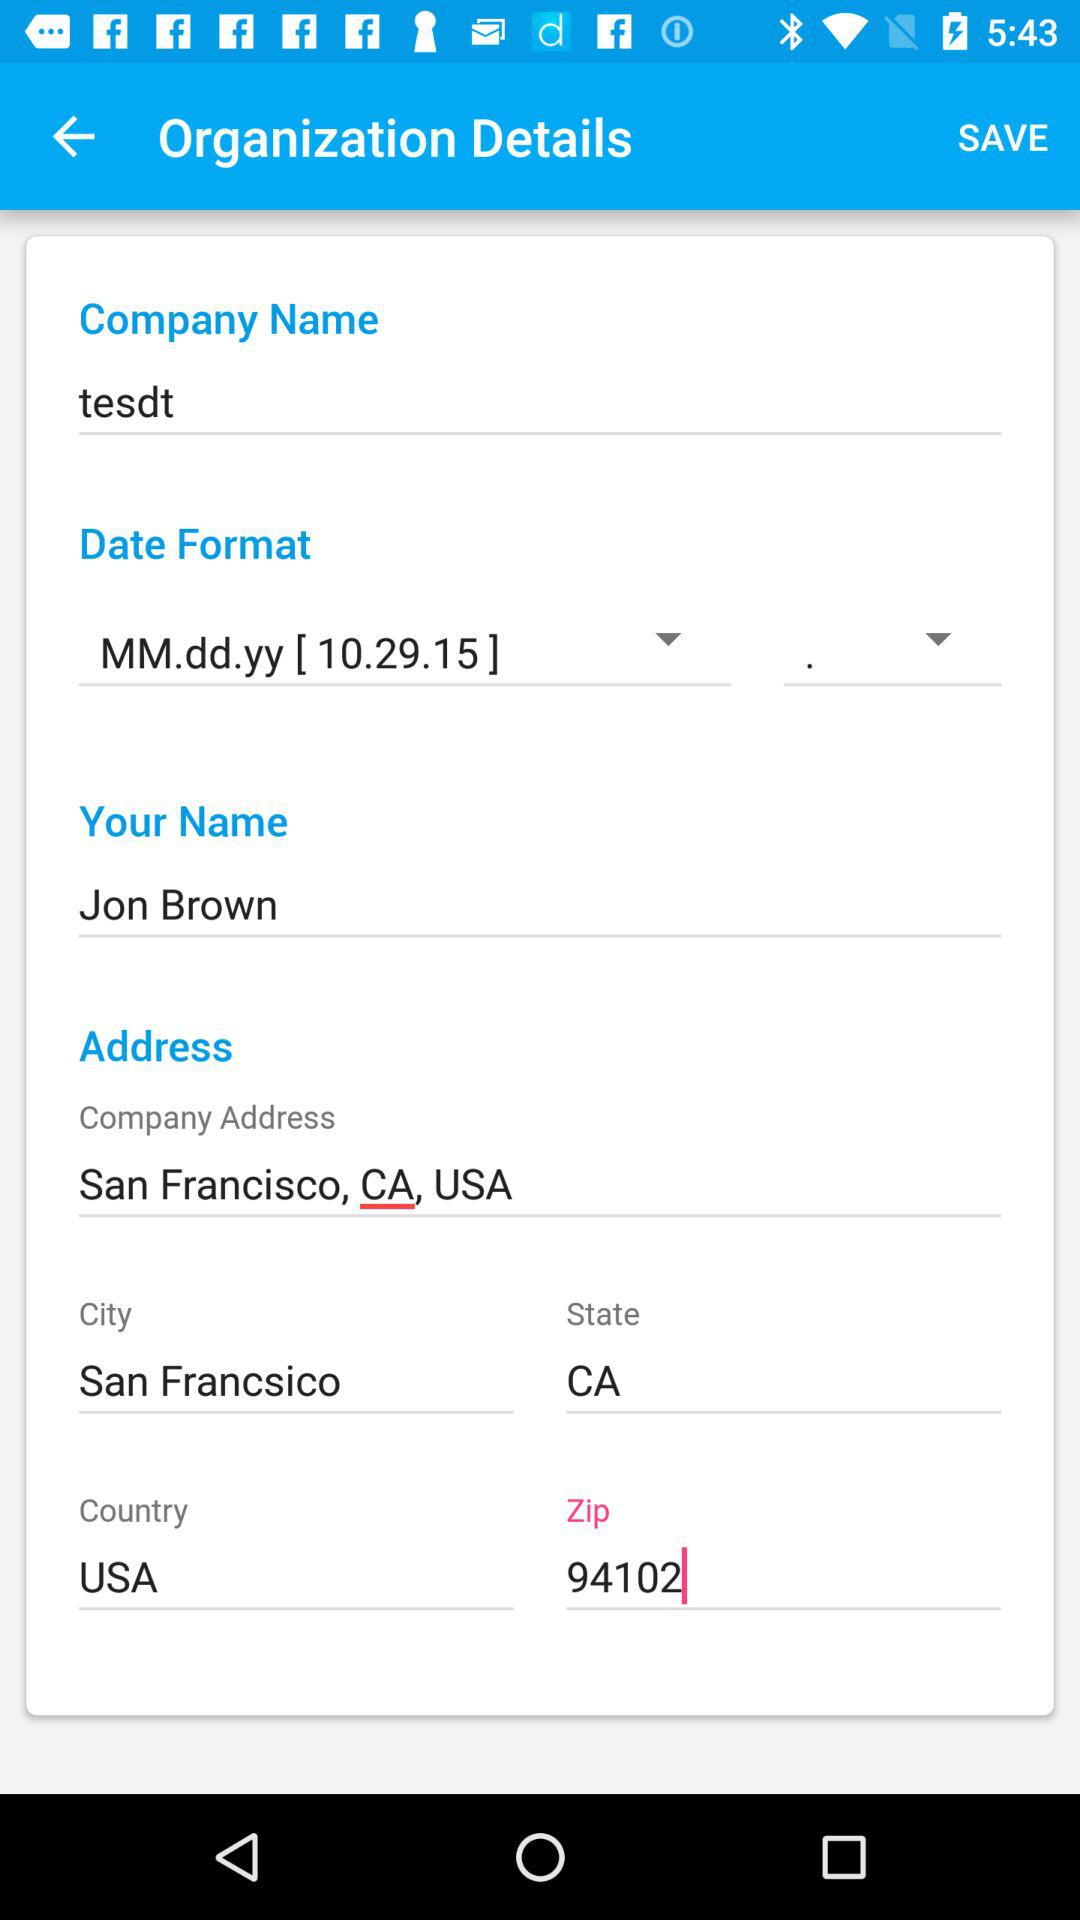What is the company name? The company name is "tesdt". 